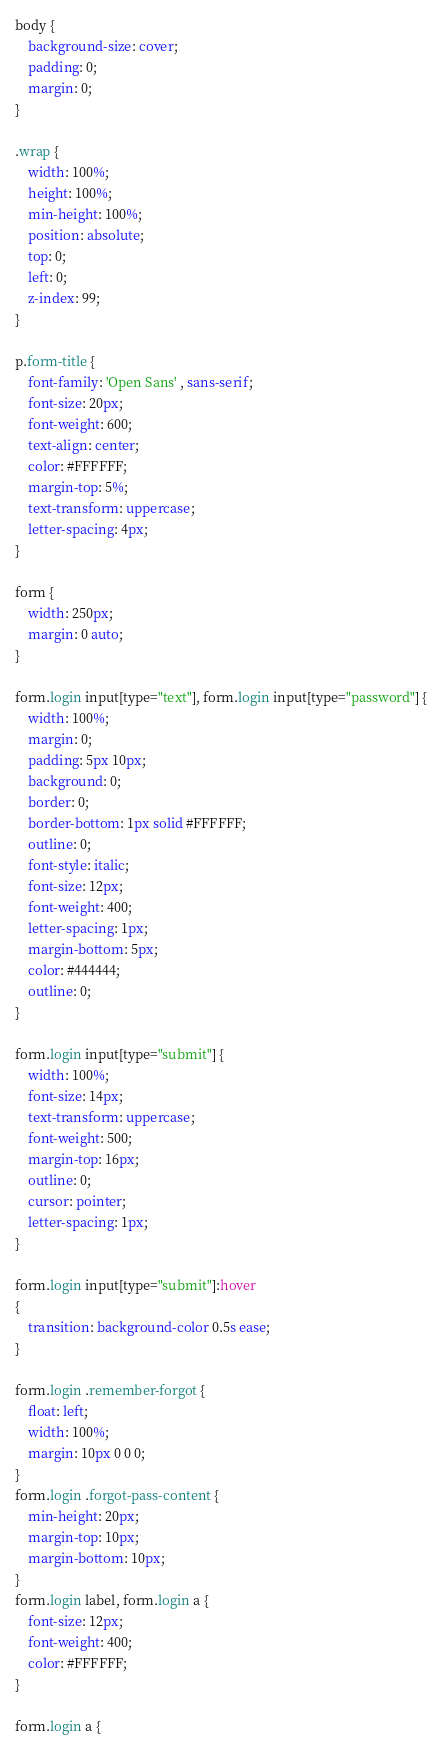<code> <loc_0><loc_0><loc_500><loc_500><_CSS_>body {
    background-size: cover;
    padding: 0;
    margin: 0;
}

.wrap {
    width: 100%;
    height: 100%;
    min-height: 100%;
    position: absolute;
    top: 0;
    left: 0;
    z-index: 99;
}

p.form-title {
    font-family: 'Open Sans' , sans-serif;
    font-size: 20px;
    font-weight: 600;
    text-align: center;
    color: #FFFFFF;
    margin-top: 5%;
    text-transform: uppercase;
    letter-spacing: 4px;
}

form {
    width: 250px;
    margin: 0 auto;
}

form.login input[type="text"], form.login input[type="password"] {
    width: 100%;
    margin: 0;
    padding: 5px 10px;
    background: 0;
    border: 0;
    border-bottom: 1px solid #FFFFFF;
    outline: 0;
    font-style: italic;
    font-size: 12px;
    font-weight: 400;
    letter-spacing: 1px;
    margin-bottom: 5px;
    color: #444444;
    outline: 0;
}

form.login input[type="submit"] {
    width: 100%;
    font-size: 14px;
    text-transform: uppercase;
    font-weight: 500;
    margin-top: 16px;
    outline: 0;
    cursor: pointer;
    letter-spacing: 1px;
}

form.login input[type="submit"]:hover
{
    transition: background-color 0.5s ease;
}

form.login .remember-forgot {
    float: left;
    width: 100%;
    margin: 10px 0 0 0;
}
form.login .forgot-pass-content {
    min-height: 20px;
    margin-top: 10px;
    margin-bottom: 10px;
}
form.login label, form.login a {
    font-size: 12px;
    font-weight: 400;
    color: #FFFFFF;
}

form.login a {</code> 